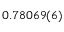<formula> <loc_0><loc_0><loc_500><loc_500>0 . 7 8 0 6 9 ( 6 )</formula> 